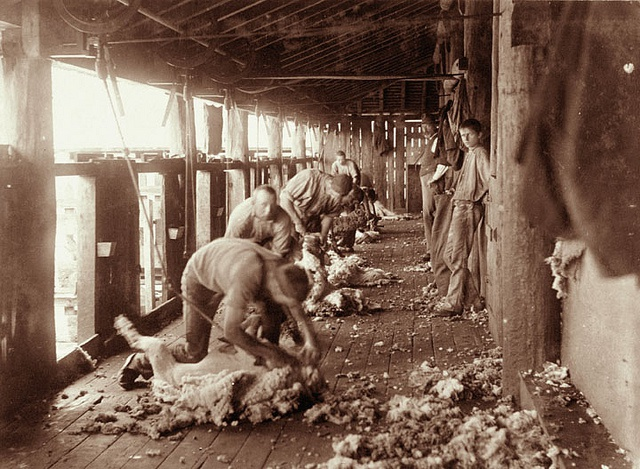Describe the objects in this image and their specific colors. I can see people in gray, maroon, black, and tan tones, sheep in gray and tan tones, people in gray, maroon, and tan tones, people in gray, maroon, black, and tan tones, and people in gray, maroon, beige, and tan tones in this image. 